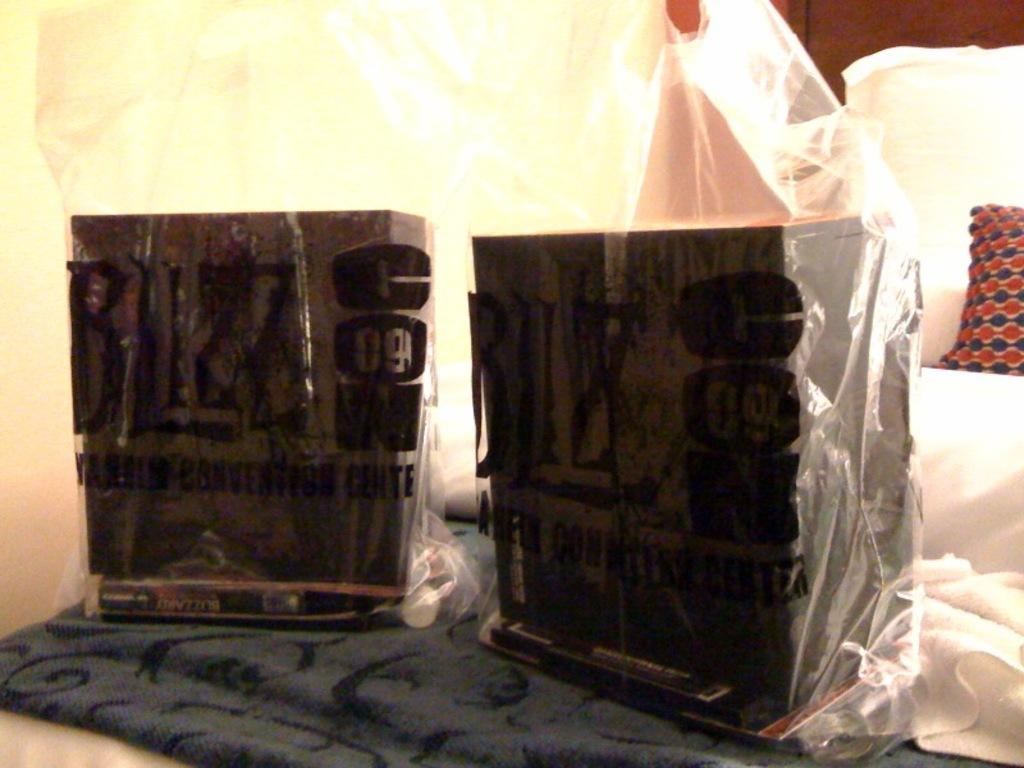What can be seen in the image that appears to be sealed or closed? There are two sealed objects in the image. What is the sealed objects placed on? The sealed objects are on a cloth. Where is the cloth with the sealed objects located? The cloth with the sealed objects is on a bed. What type of yak can be seen in the image? There is no yak present in the image. What kind of smell is emanating from the sealed objects in the image? The image does not provide any information about the smell of the sealed objects. --- 